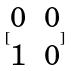Convert formula to latex. <formula><loc_0><loc_0><loc_500><loc_500>[ \begin{matrix} 0 & 0 \\ 1 & 0 \end{matrix} ]</formula> 